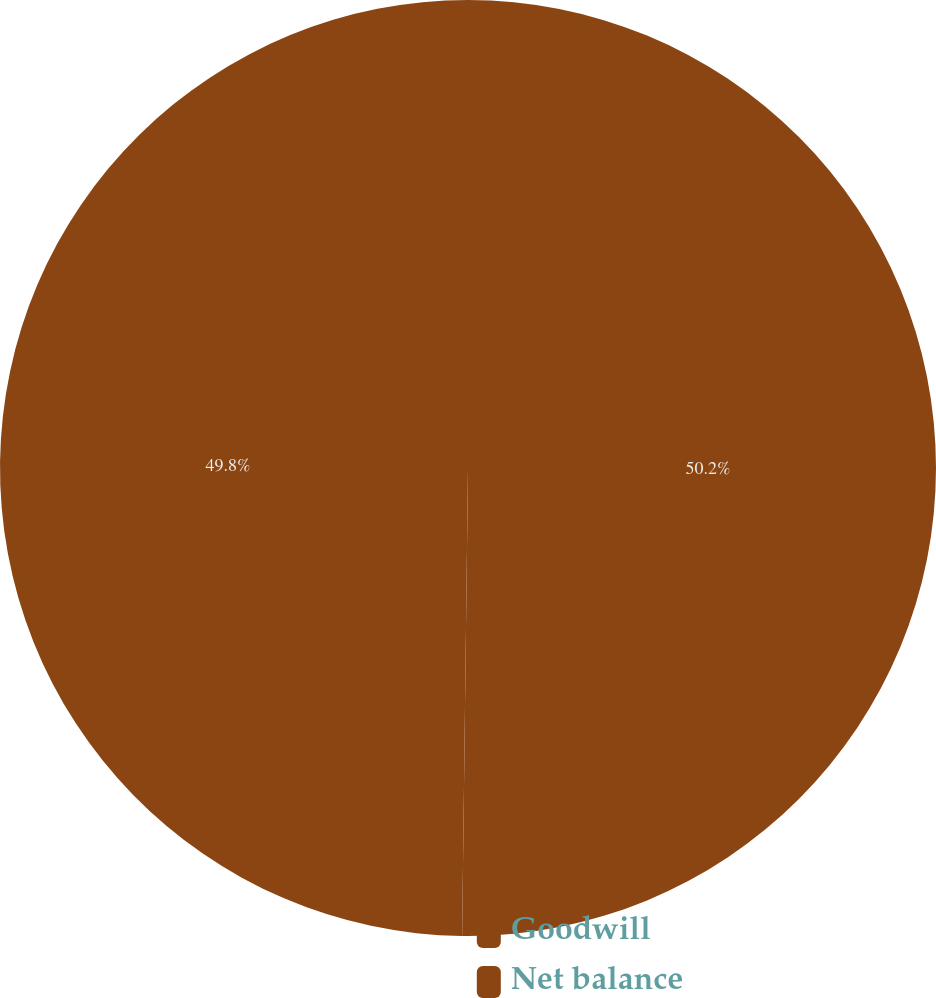<chart> <loc_0><loc_0><loc_500><loc_500><pie_chart><fcel>Goodwill<fcel>Net balance<nl><fcel>50.2%<fcel>49.8%<nl></chart> 